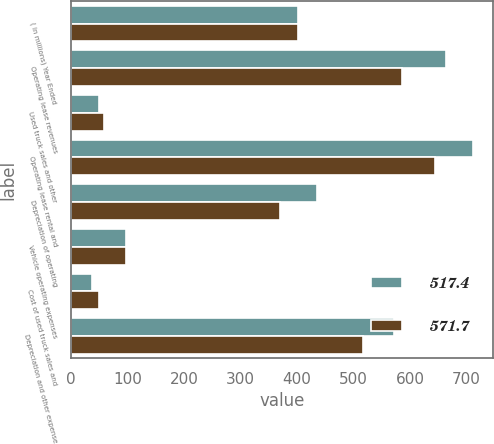Convert chart. <chart><loc_0><loc_0><loc_500><loc_500><stacked_bar_chart><ecel><fcel>( in millions) Year Ended<fcel>Operating lease revenues<fcel>Used truck sales and other<fcel>Operating lease rental and<fcel>Depreciation of operating<fcel>Vehicle operating expenses<fcel>Cost of used truck sales and<fcel>Depreciation and other expense<nl><fcel>517.4<fcel>402.65<fcel>663<fcel>49.1<fcel>712.1<fcel>435.4<fcel>98.1<fcel>38.2<fcel>571.7<nl><fcel>571.7<fcel>402.65<fcel>585.9<fcel>59.2<fcel>645.1<fcel>369.9<fcel>97<fcel>50.5<fcel>517.4<nl></chart> 